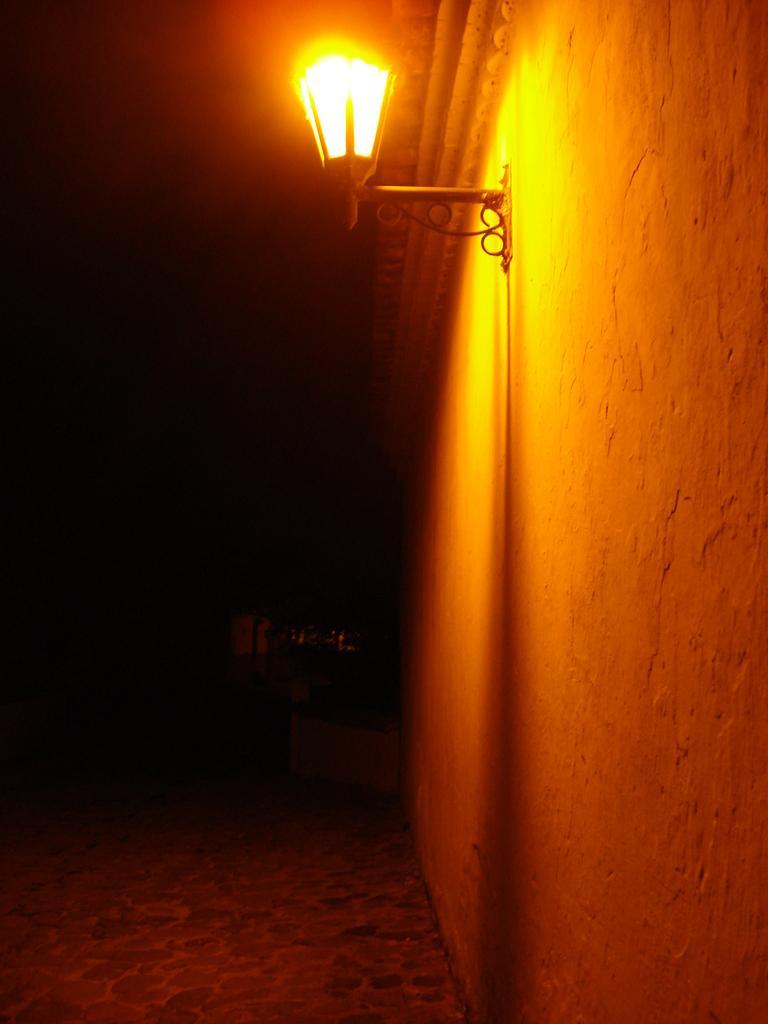Describe this image in one or two sentences. In this picture there is lamp at the top side of the image and the background area of the image is dark. 